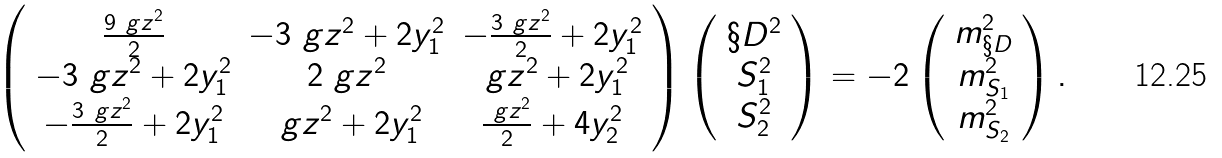Convert formula to latex. <formula><loc_0><loc_0><loc_500><loc_500>\left ( \begin{array} { c c c } \frac { 9 \ g z ^ { 2 } } { 2 } & - 3 \ g z ^ { 2 } + 2 y _ { 1 } ^ { 2 } & - \frac { 3 \ g z ^ { 2 } } { 2 } + 2 y _ { 1 } ^ { 2 } \\ - 3 \ g z ^ { 2 } + 2 y _ { 1 } ^ { 2 } & 2 \ g z ^ { 2 } & \ g z ^ { 2 } + 2 y _ { 1 } ^ { 2 } \\ - \frac { 3 \ g z ^ { 2 } } { 2 } + 2 y _ { 1 } ^ { 2 } & \ g z ^ { 2 } + 2 y _ { 1 } ^ { 2 } & \frac { \ g z ^ { 2 } } { 2 } + 4 y _ { 2 } ^ { 2 } \end{array} \right ) \left ( \begin{array} { c } \S D ^ { 2 } \\ S _ { 1 } ^ { 2 } \\ S _ { 2 } ^ { 2 } \end{array} \right ) = - 2 \left ( \begin{array} { c } m _ { \S D } ^ { 2 } \\ m _ { S _ { 1 } } ^ { 2 } \\ m _ { S _ { 2 } } ^ { 2 } \end{array} \right ) .</formula> 